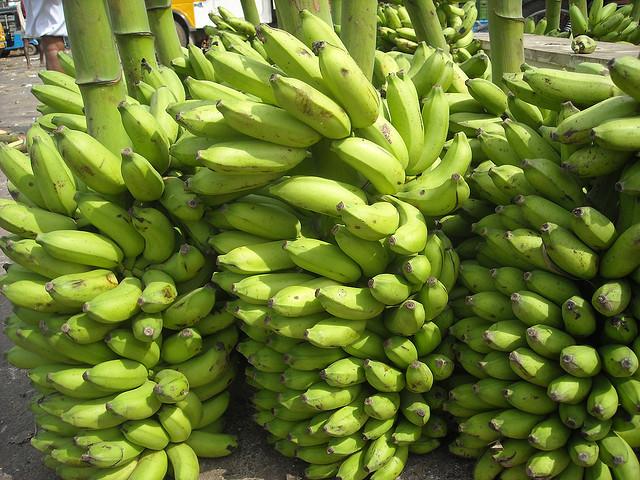Are the bananas on a tree?
Short answer required. No. Is there more than one type of fruit pictured?
Keep it brief. No. Are the bananas still on the tree?
Keep it brief. No. Which direction are the bananas pointing?
Concise answer only. Up. How many bananas are in the picture?
Answer briefly. 100. Are the bananas on the ground?
Concise answer only. Yes. 